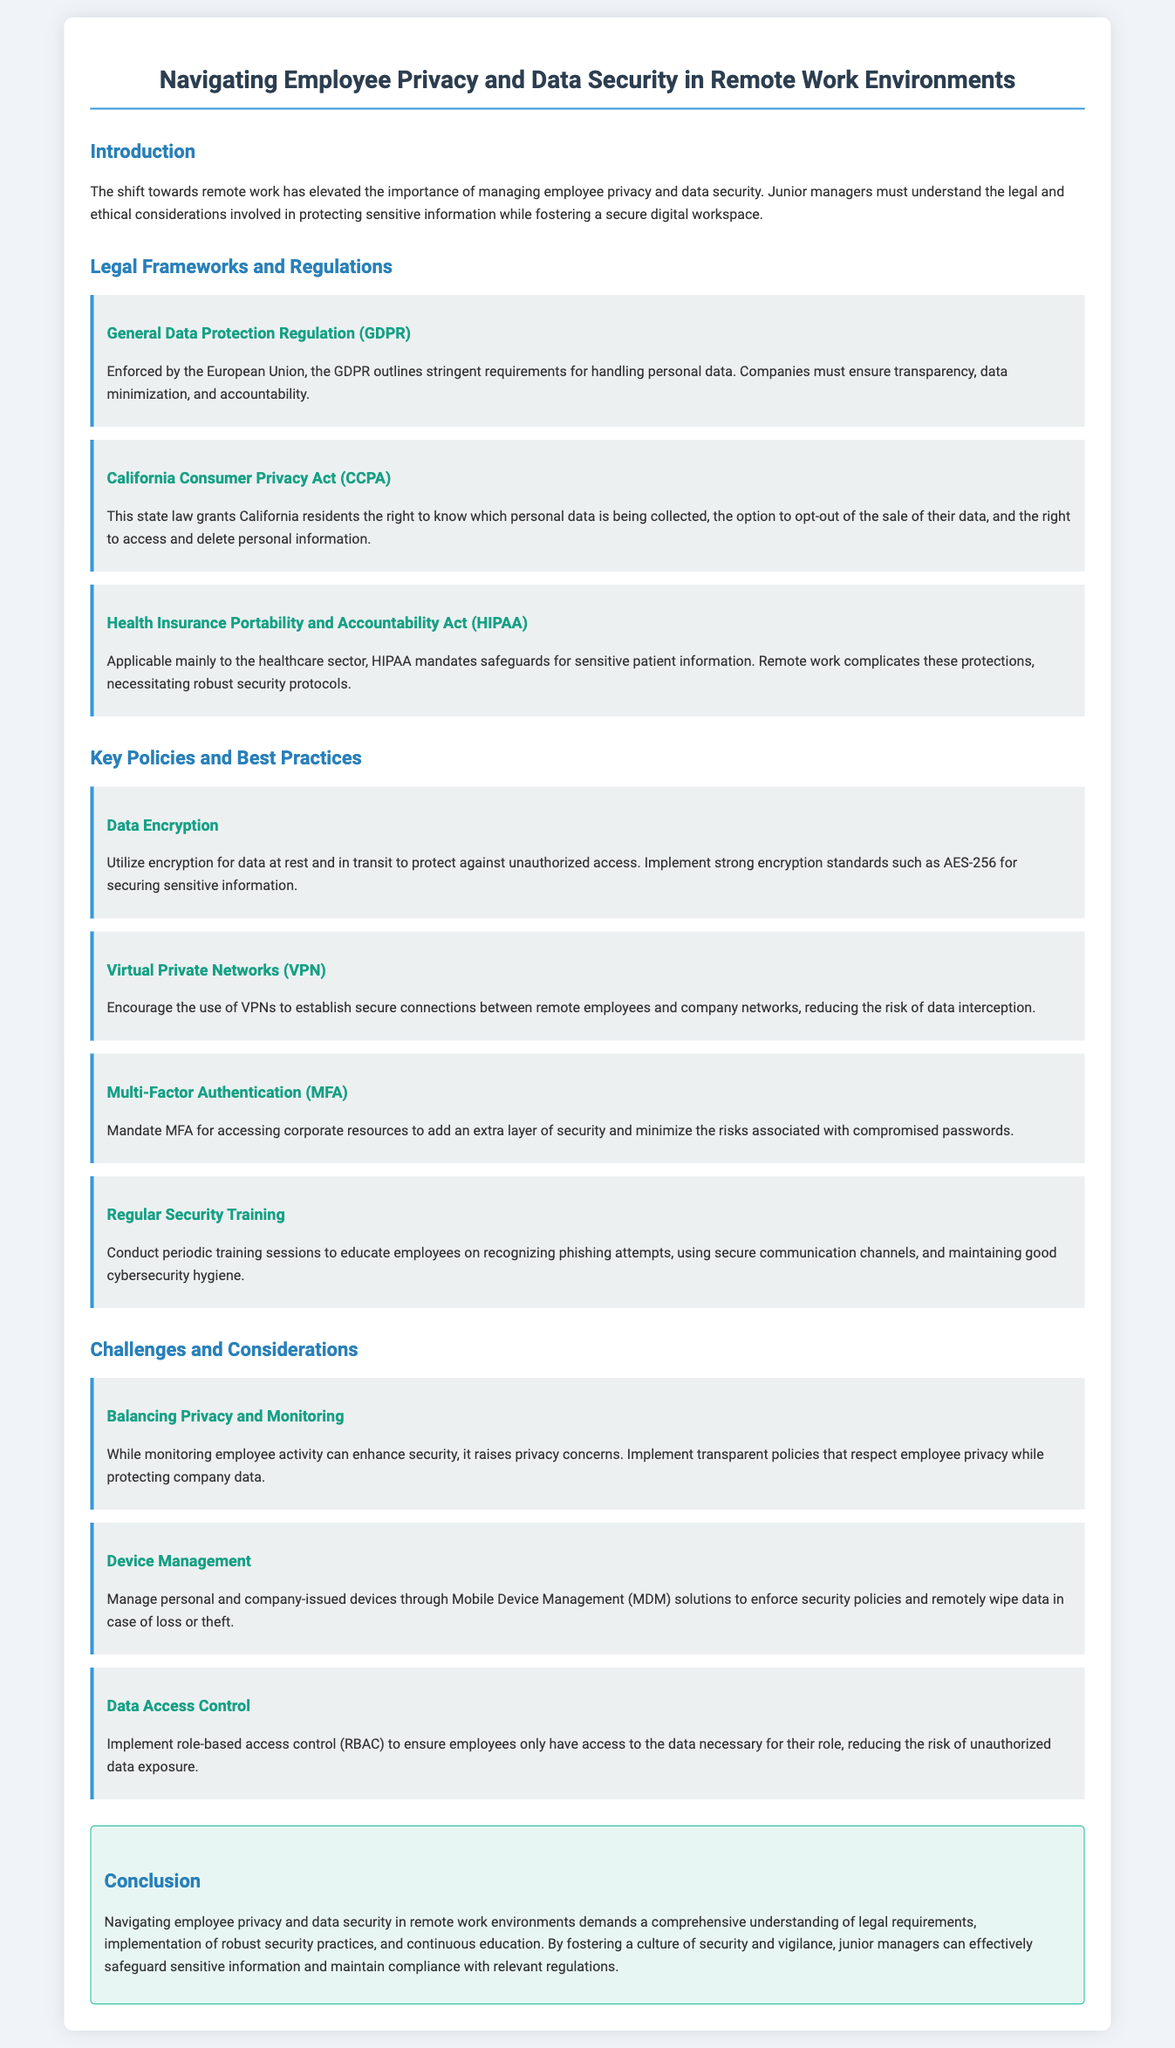What is the title of the document? The title of the document is presented prominently at the top of the content.
Answer: Navigating Employee Privacy and Data Security in Remote Work Environments Which regulation is enforced by the European Union? This regulation is specifically mentioned under the Legal Frameworks and Regulations section.
Answer: General Data Protection Regulation (GDPR) What act grants California residents the right to know which personal data is being collected? This act is listed as part of the Legal Frameworks and Regulations, describing its purpose.
Answer: California Consumer Privacy Act (CCPA) What is the recommended encryption standard mentioned in the document? This is specified under the Key Policies and Best Practices section, providing specific guidance.
Answer: AES-256 How many types of regulations are discussed in the document? The document lists three distinct regulations related to employee privacy and data security.
Answer: three What is a key method for reducing the risk of data interception? This is noted under Key Policies and Best Practices, suggesting a specific tool for security.
Answer: Virtual Private Networks (VPN) What does HIPAA mainly apply to? The document describes the specific sector that this regulation is focused on.
Answer: healthcare sector What does RBAC stand for? The term is defined within the context of managing data access in the Challenges and Considerations section.
Answer: role-based access control (RBAC) What is mandatory for accessing corporate resources according to the best practices? This policy adds an extra layer of security and is mentioned as a requirement.
Answer: Multi-Factor Authentication (MFA) 